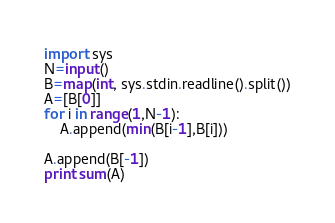<code> <loc_0><loc_0><loc_500><loc_500><_Python_>import sys
N=input()
B=map(int, sys.stdin.readline().split())
A=[B[0]]
for i in range(1,N-1):
    A.append(min(B[i-1],B[i]))
    
A.append(B[-1])
print sum(A)</code> 